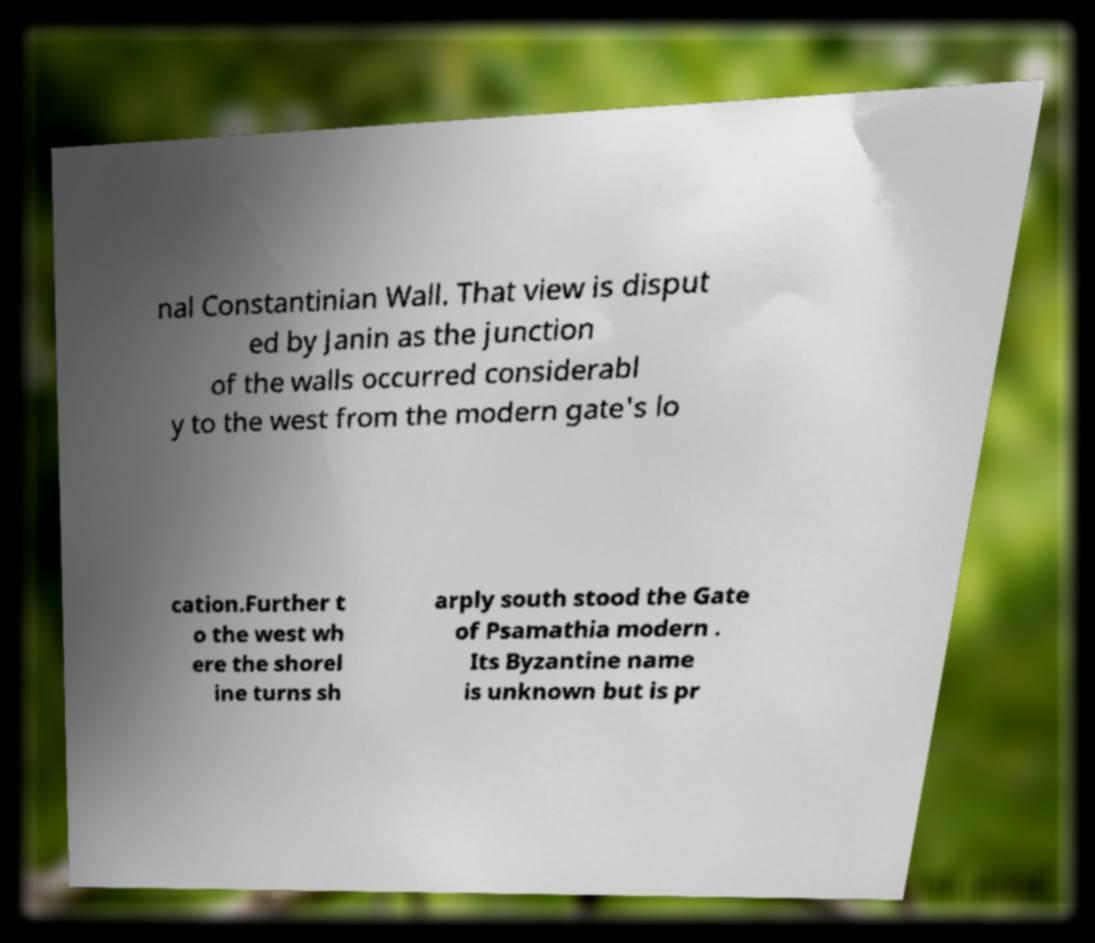Please identify and transcribe the text found in this image. nal Constantinian Wall. That view is disput ed by Janin as the junction of the walls occurred considerabl y to the west from the modern gate's lo cation.Further t o the west wh ere the shorel ine turns sh arply south stood the Gate of Psamathia modern . Its Byzantine name is unknown but is pr 